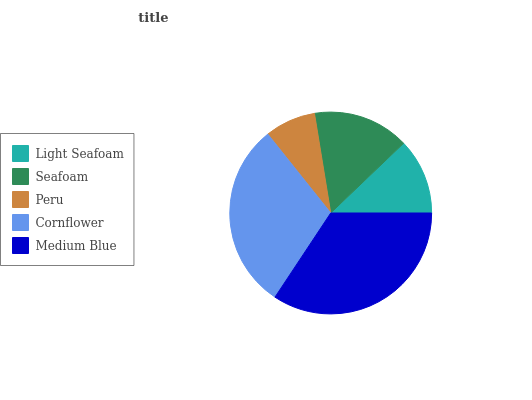Is Peru the minimum?
Answer yes or no. Yes. Is Medium Blue the maximum?
Answer yes or no. Yes. Is Seafoam the minimum?
Answer yes or no. No. Is Seafoam the maximum?
Answer yes or no. No. Is Seafoam greater than Light Seafoam?
Answer yes or no. Yes. Is Light Seafoam less than Seafoam?
Answer yes or no. Yes. Is Light Seafoam greater than Seafoam?
Answer yes or no. No. Is Seafoam less than Light Seafoam?
Answer yes or no. No. Is Seafoam the high median?
Answer yes or no. Yes. Is Seafoam the low median?
Answer yes or no. Yes. Is Cornflower the high median?
Answer yes or no. No. Is Light Seafoam the low median?
Answer yes or no. No. 